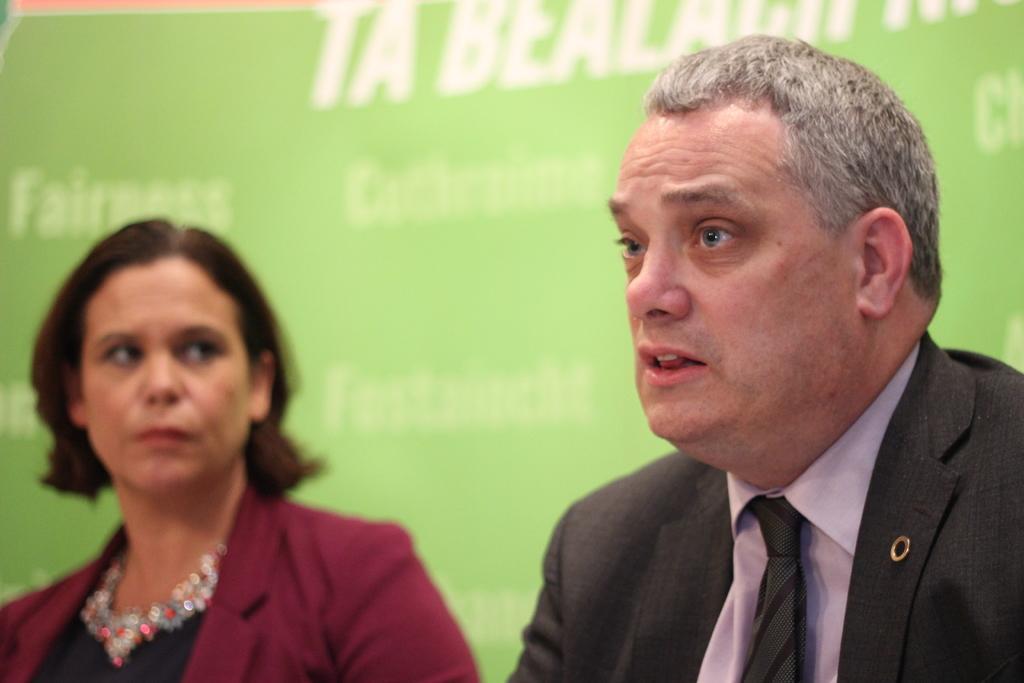How would you summarize this image in a sentence or two? As we can see in the image there are two people and green color banner. 